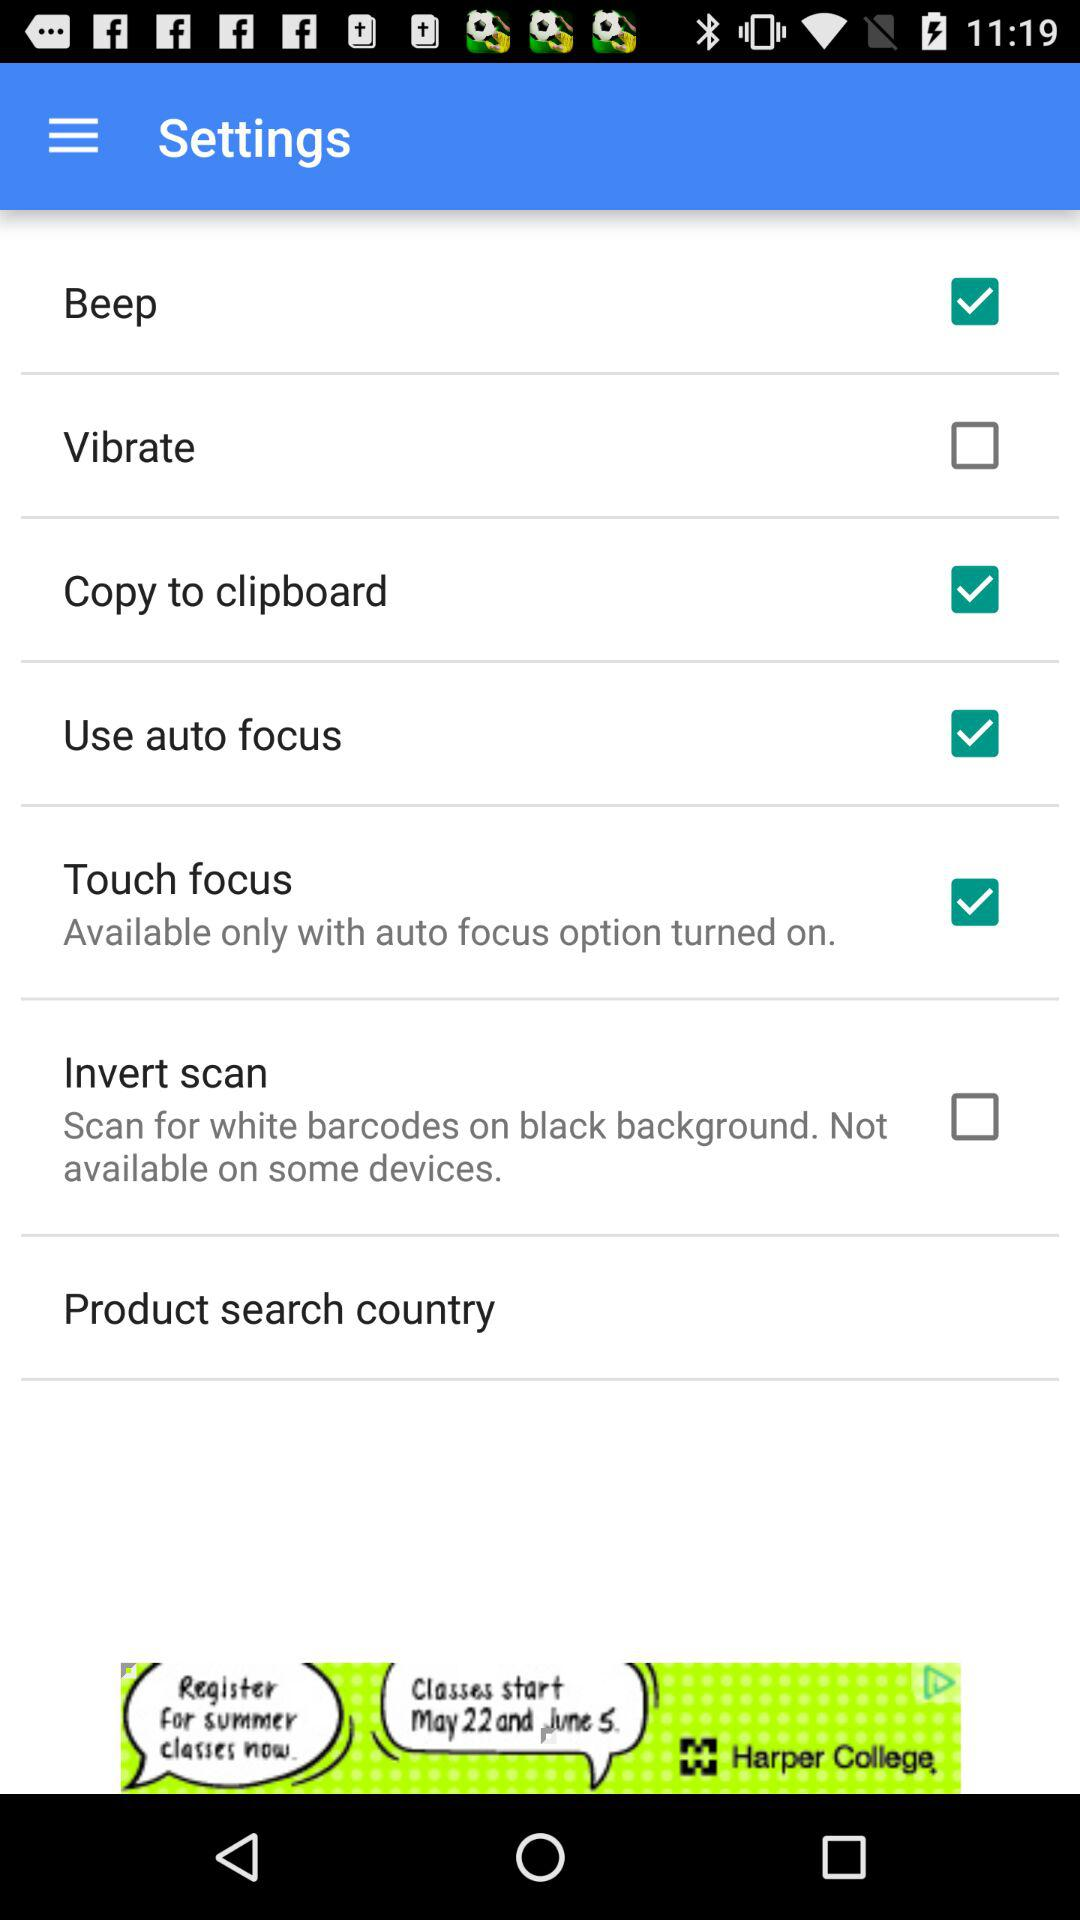How many checkboxes are available only with auto focus option turned on?
Answer the question using a single word or phrase. 2 